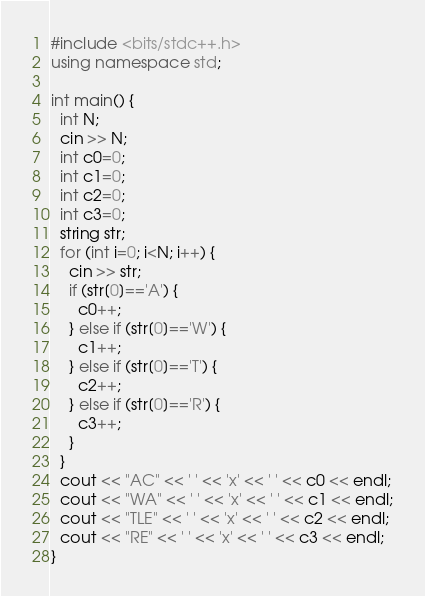<code> <loc_0><loc_0><loc_500><loc_500><_C++_>#include <bits/stdc++.h>
using namespace std;

int main() {
  int N;
  cin >> N;
  int c0=0;
  int c1=0;
  int c2=0;
  int c3=0;
  string str;
  for (int i=0; i<N; i++) {
    cin >> str;
    if (str[0]=='A') {
      c0++;
    } else if (str[0]=='W') {
      c1++;
    } else if (str[0]=='T') {
      c2++;
    } else if (str[0]=='R') {
      c3++;
    }
  }
  cout << "AC" << ' ' << 'x' << ' ' << c0 << endl;
  cout << "WA" << ' ' << 'x' << ' ' << c1 << endl;
  cout << "TLE" << ' ' << 'x' << ' ' << c2 << endl;
  cout << "RE" << ' ' << 'x' << ' ' << c3 << endl;
}</code> 